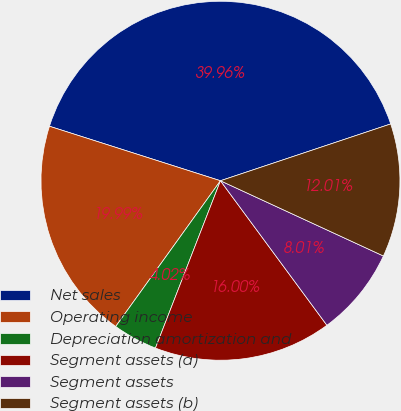Convert chart to OTSL. <chart><loc_0><loc_0><loc_500><loc_500><pie_chart><fcel>Net sales<fcel>Operating income<fcel>Depreciation amortization and<fcel>Segment assets (a)<fcel>Segment assets<fcel>Segment assets (b)<nl><fcel>39.96%<fcel>19.99%<fcel>4.02%<fcel>16.0%<fcel>8.01%<fcel>12.01%<nl></chart> 